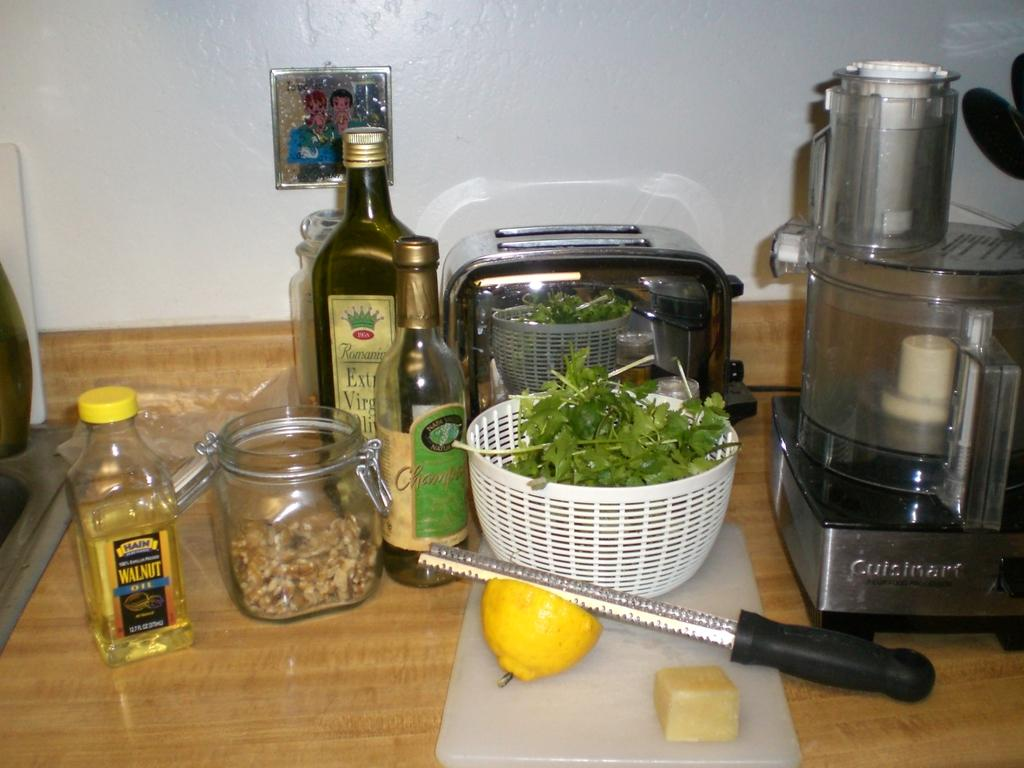<image>
Give a short and clear explanation of the subsequent image. A bottle of walnut oil can be seen next to greens in a bowl. 